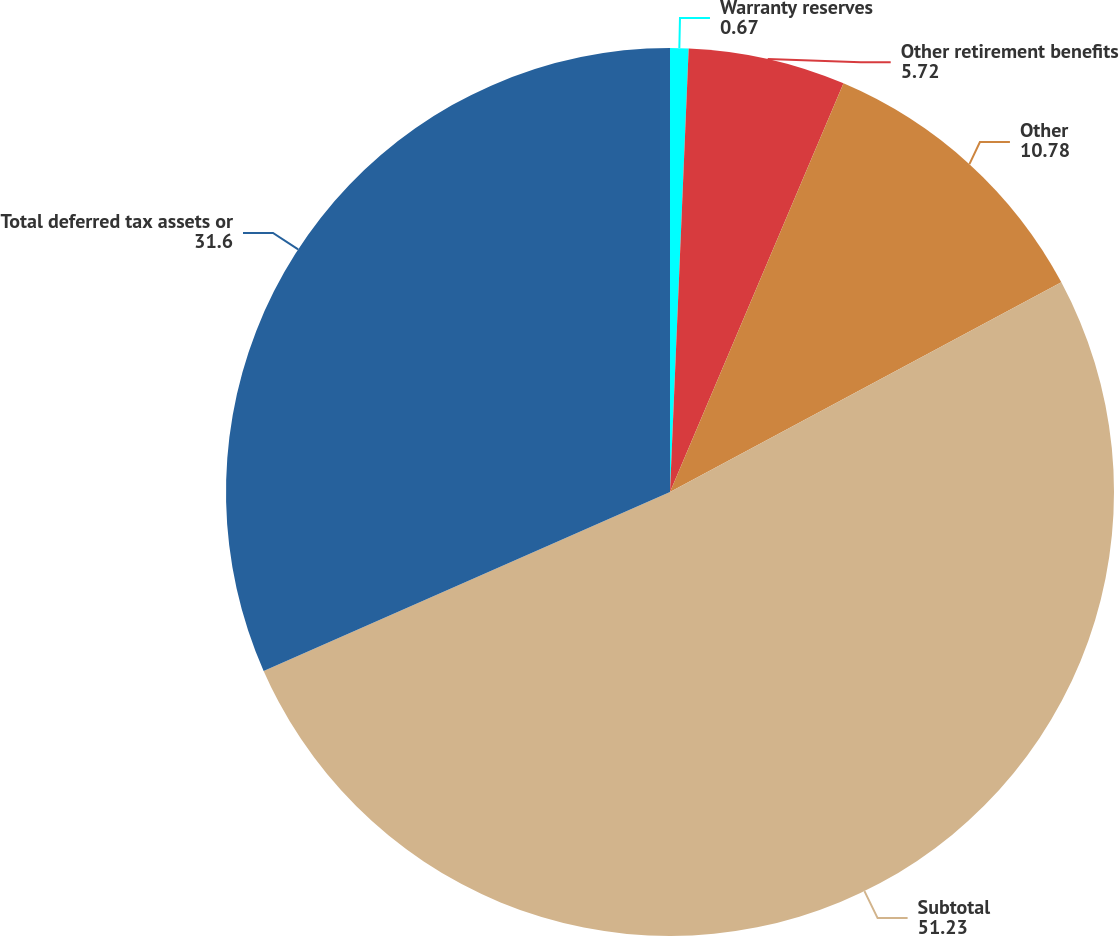Convert chart to OTSL. <chart><loc_0><loc_0><loc_500><loc_500><pie_chart><fcel>Warranty reserves<fcel>Other retirement benefits<fcel>Other<fcel>Subtotal<fcel>Total deferred tax assets or<nl><fcel>0.67%<fcel>5.72%<fcel>10.78%<fcel>51.23%<fcel>31.6%<nl></chart> 